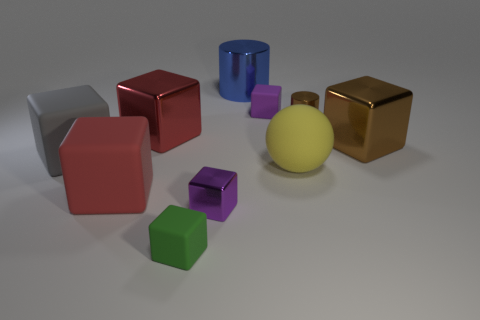Subtract all red matte cubes. How many cubes are left? 6 Subtract all cyan spheres. How many purple cubes are left? 2 Subtract 3 cubes. How many cubes are left? 4 Subtract all cylinders. How many objects are left? 8 Subtract all blue cylinders. How many cylinders are left? 1 Subtract 0 purple balls. How many objects are left? 10 Subtract all gray cylinders. Subtract all purple spheres. How many cylinders are left? 2 Subtract all tiny brown rubber cylinders. Subtract all tiny matte blocks. How many objects are left? 8 Add 3 green rubber cubes. How many green rubber cubes are left? 4 Add 4 small purple rubber balls. How many small purple rubber balls exist? 4 